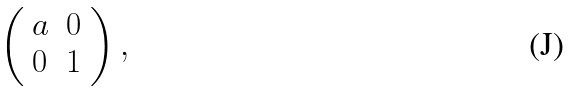<formula> <loc_0><loc_0><loc_500><loc_500>\left ( \begin{array} { l l } a & 0 \\ 0 & 1 \end{array} \right ) ,</formula> 